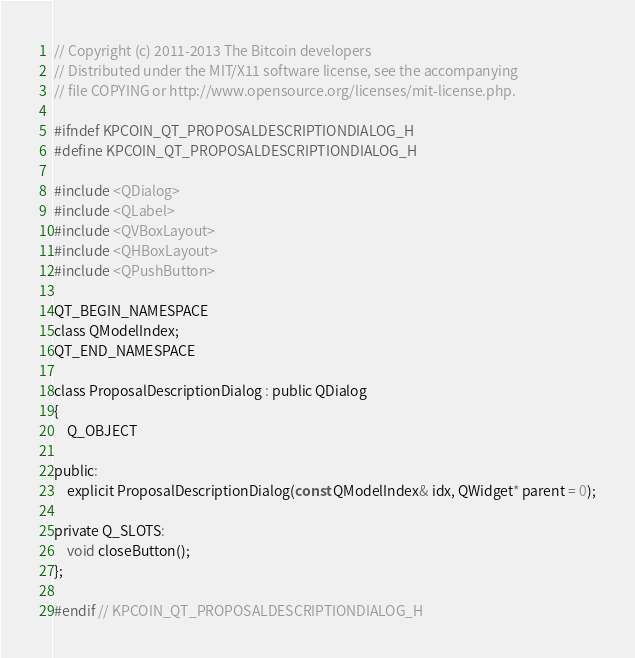Convert code to text. <code><loc_0><loc_0><loc_500><loc_500><_C_>// Copyright (c) 2011-2013 The Bitcoin developers
// Distributed under the MIT/X11 software license, see the accompanying
// file COPYING or http://www.opensource.org/licenses/mit-license.php.

#ifndef KPCOIN_QT_PROPOSALDESCRIPTIONDIALOG_H
#define KPCOIN_QT_PROPOSALDESCRIPTIONDIALOG_H

#include <QDialog>
#include <QLabel>
#include <QVBoxLayout>
#include <QHBoxLayout>
#include <QPushButton>

QT_BEGIN_NAMESPACE
class QModelIndex;
QT_END_NAMESPACE

class ProposalDescriptionDialog : public QDialog
{
    Q_OBJECT

public:
    explicit ProposalDescriptionDialog(const QModelIndex& idx, QWidget* parent = 0);

private Q_SLOTS:
    void closeButton();
};

#endif // KPCOIN_QT_PROPOSALDESCRIPTIONDIALOG_H
</code> 